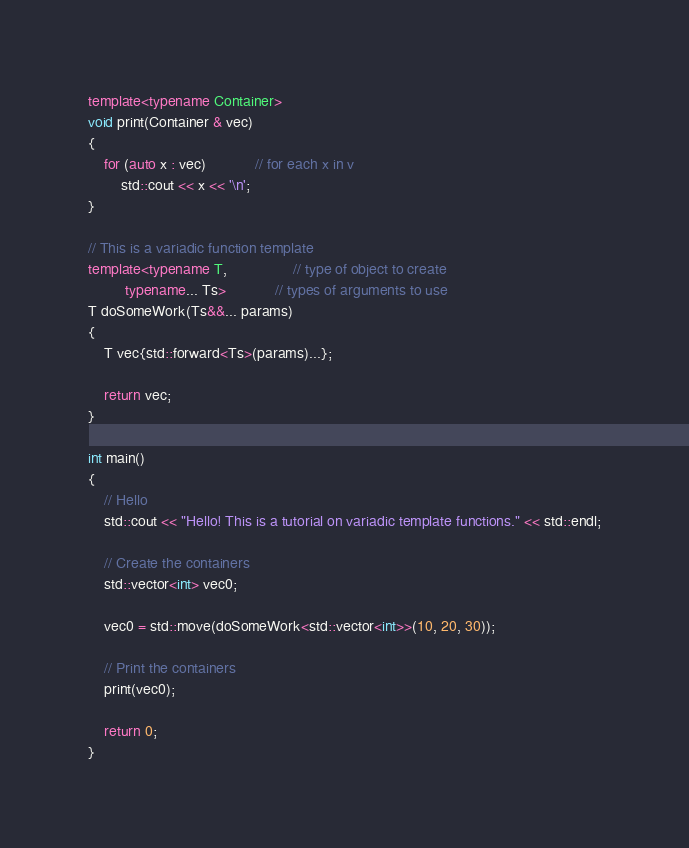<code> <loc_0><loc_0><loc_500><loc_500><_C++_>template<typename Container>
void print(Container & vec)
{
    for (auto x : vec)            // for each x in v
        std::cout << x << '\n';
}

// This is a variadic function template
template<typename T,                // type of object to create
         typename... Ts>            // types of arguments to use
T doSomeWork(Ts&&... params)
{
    T vec{std::forward<Ts>(params)...};
    
    return vec;
}

int main()
{
    // Hello
    std::cout << "Hello! This is a tutorial on variadic template functions." << std::endl;

    // Create the containers
    std::vector<int> vec0;

    vec0 = std::move(doSomeWork<std::vector<int>>(10, 20, 30));

    // Print the containers
    print(vec0);

    return 0;
}

</code> 